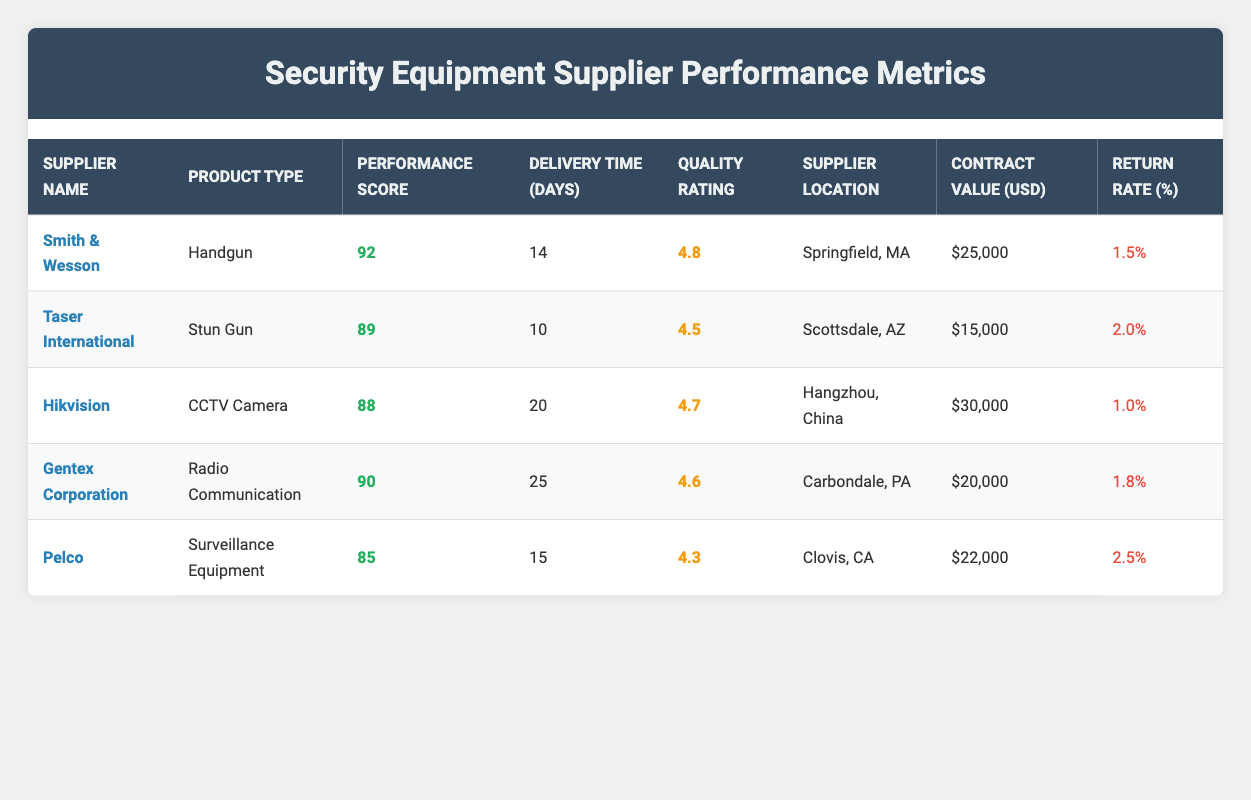What is the Supplier Name with the highest Performance Score? The table shows the Performance Scores for each supplier. By comparing them: Smith & Wesson has a score of 92, which is higher than the others (Taser International 89, Hikvision 88, Gentex Corporation 90, Pelco 85). Therefore, the Supplier with the highest Performance Score is Smith & Wesson.
Answer: Smith & Wesson What is the average Delivery Time of all suppliers? To find the average Delivery Time, we add the Delivery Times together: (14 + 10 + 20 + 25 + 15) = 94 days. We then divide by the number of suppliers (5): 94/5 = 18.8 days.
Answer: 18.8 days Which supplier has the lowest Return Rate? The Return Rates for all suppliers are 1.5%, 2.0%, 1.0%, 1.8%, and 2.5%. By comparing these values, we see that Hikvision has the lowest Return Rate at 1.0%.
Answer: Hikvision Is the Quality Rating of Gentex Corporation greater than that of Taser International? Gentex Corporation has a Quality Rating of 4.6, while Taser International has a Quality Rating of 4.5. Since 4.6 is greater than 4.5, the statement is true.
Answer: Yes What is the total Contract Value of suppliers located in the United States? First, we identify the suppliers located in the United States: Smith & Wesson ($25,000), Taser International ($15,000), Gentex Corporation ($20,000), and Pelco ($22,000). The total Contract Value is $25,000 + $15,000 + $20,000 + $22,000 = $82,000.
Answer: $82,000 Which Product Type has a Performance Score lower than 90? The Performance Scores below 90 are: Taser International (89), Hikvision (88), Pelco (85). The Product Types corresponding to these scores are Stun Gun, CCTV Camera, and Surveillance Equipment.
Answer: Stun Gun, CCTV Camera, Surveillance Equipment What is the difference in Performance Scores between the highest and lowest scoring suppliers? The highest Performance Score is from Smith & Wesson at 92, and the lowest is from Pelco at 85. The difference is calculated as 92 - 85 = 7.
Answer: 7 Is the Quality Rating of all suppliers above 4.0? The Quality Ratings provided are: Smith & Wesson (4.8), Taser International (4.5), Hikvision (4.7), Gentex Corporation (4.6), and Pelco (4.3). Since all of these ratings are above 4.0, the answer is true.
Answer: Yes 